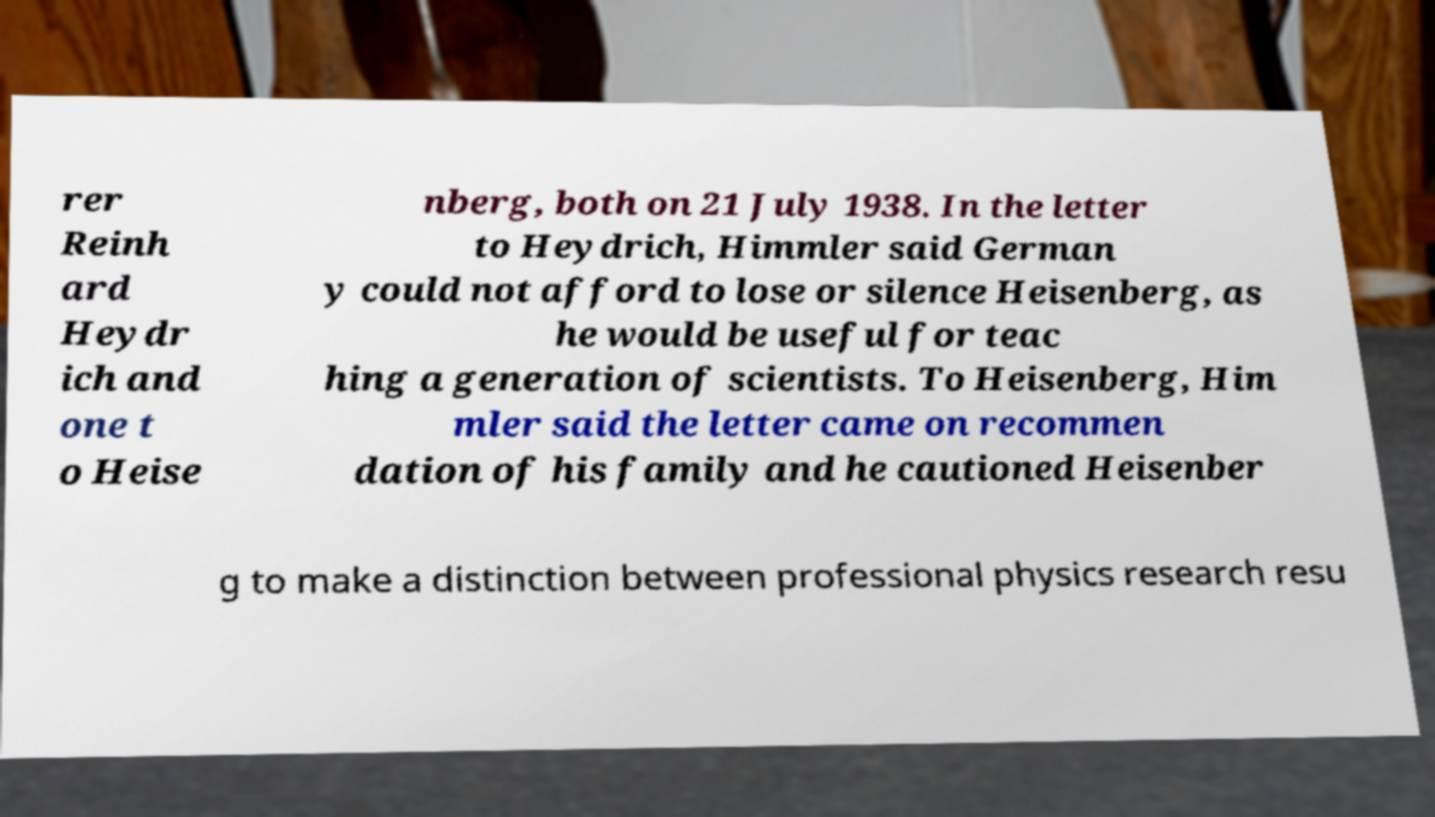Can you accurately transcribe the text from the provided image for me? rer Reinh ard Heydr ich and one t o Heise nberg, both on 21 July 1938. In the letter to Heydrich, Himmler said German y could not afford to lose or silence Heisenberg, as he would be useful for teac hing a generation of scientists. To Heisenberg, Him mler said the letter came on recommen dation of his family and he cautioned Heisenber g to make a distinction between professional physics research resu 